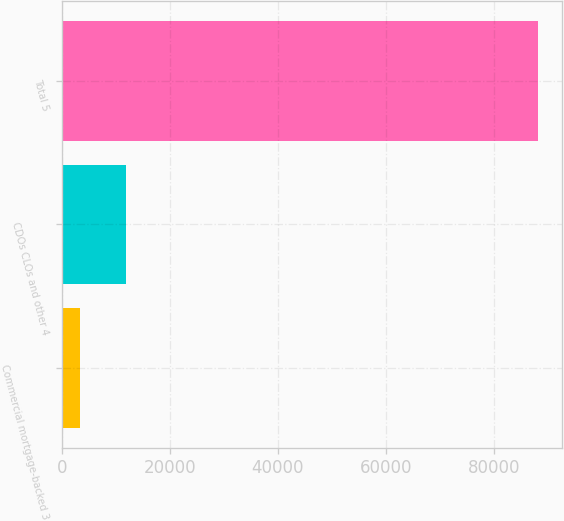Convert chart to OTSL. <chart><loc_0><loc_0><loc_500><loc_500><bar_chart><fcel>Commercial mortgage-backed 3<fcel>CDOs CLOs and other 4<fcel>Total 5<nl><fcel>3398<fcel>11885.9<fcel>88277<nl></chart> 